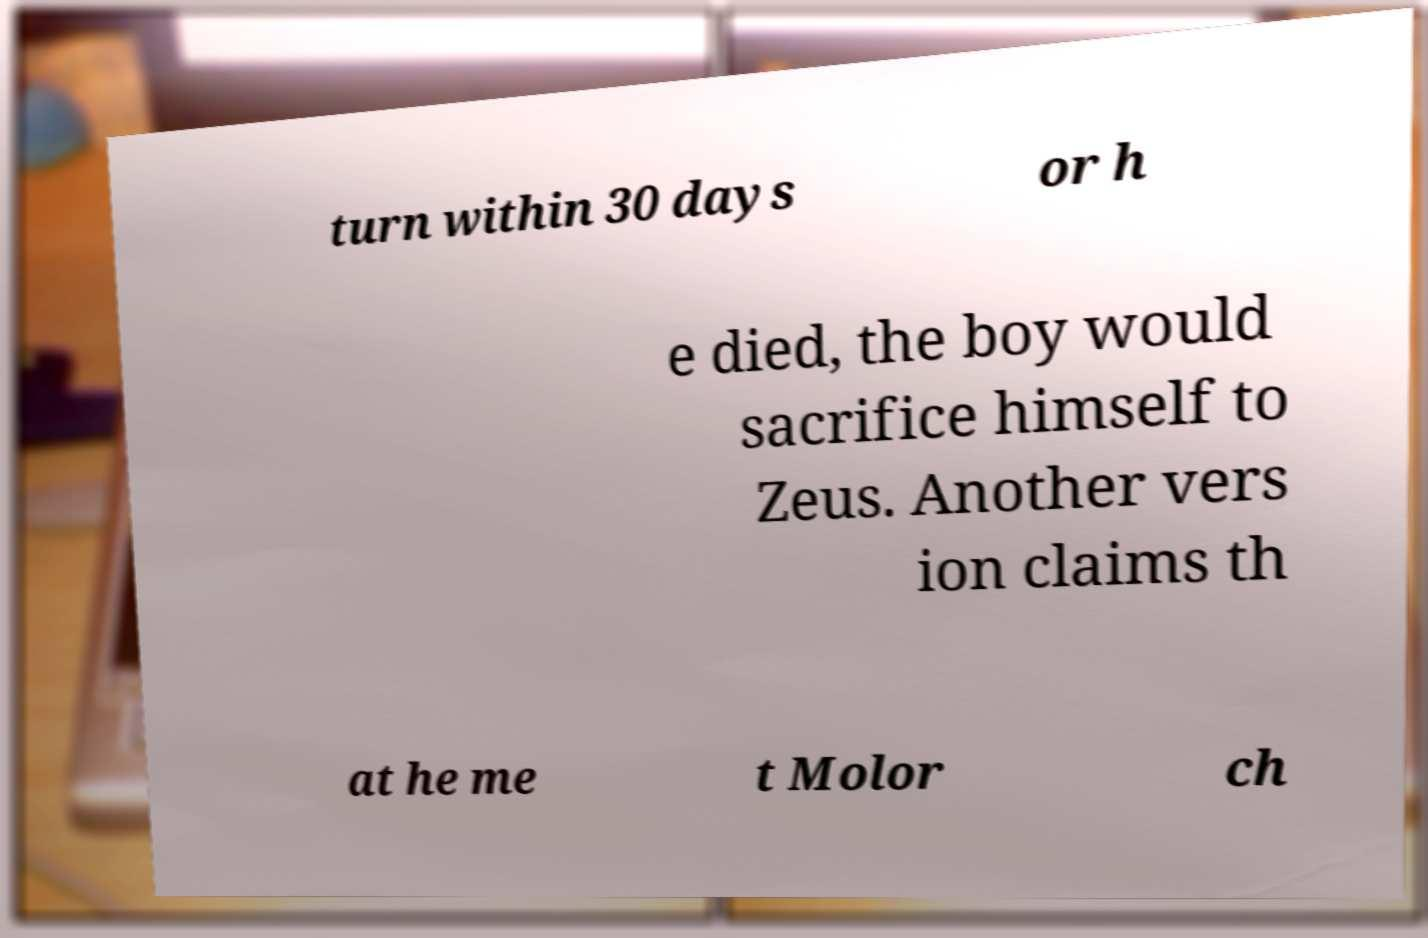Please read and relay the text visible in this image. What does it say? turn within 30 days or h e died, the boy would sacrifice himself to Zeus. Another vers ion claims th at he me t Molor ch 